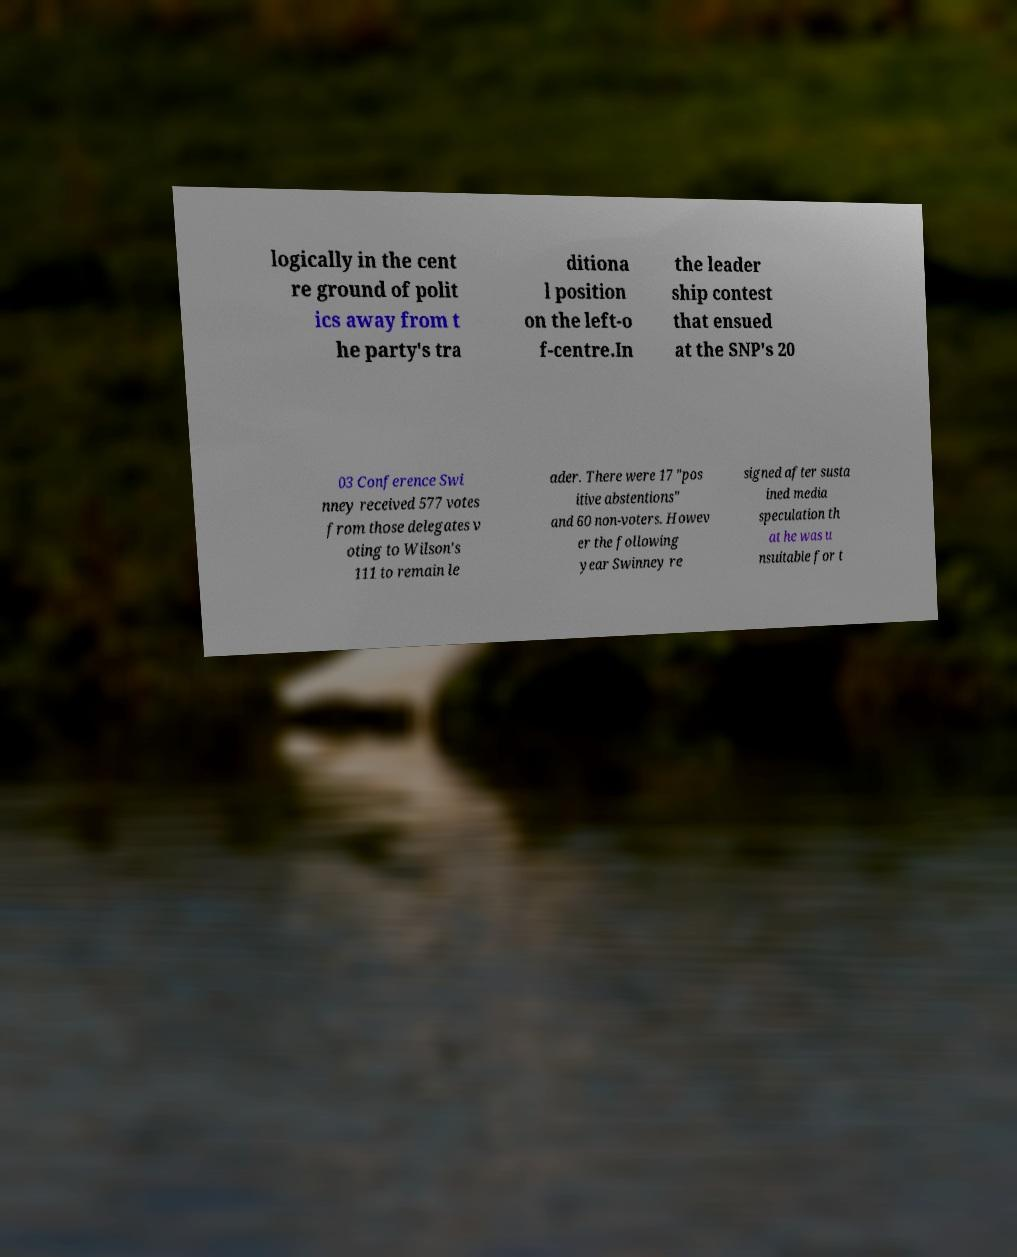For documentation purposes, I need the text within this image transcribed. Could you provide that? logically in the cent re ground of polit ics away from t he party's tra ditiona l position on the left-o f-centre.In the leader ship contest that ensued at the SNP's 20 03 Conference Swi nney received 577 votes from those delegates v oting to Wilson's 111 to remain le ader. There were 17 "pos itive abstentions" and 60 non-voters. Howev er the following year Swinney re signed after susta ined media speculation th at he was u nsuitable for t 